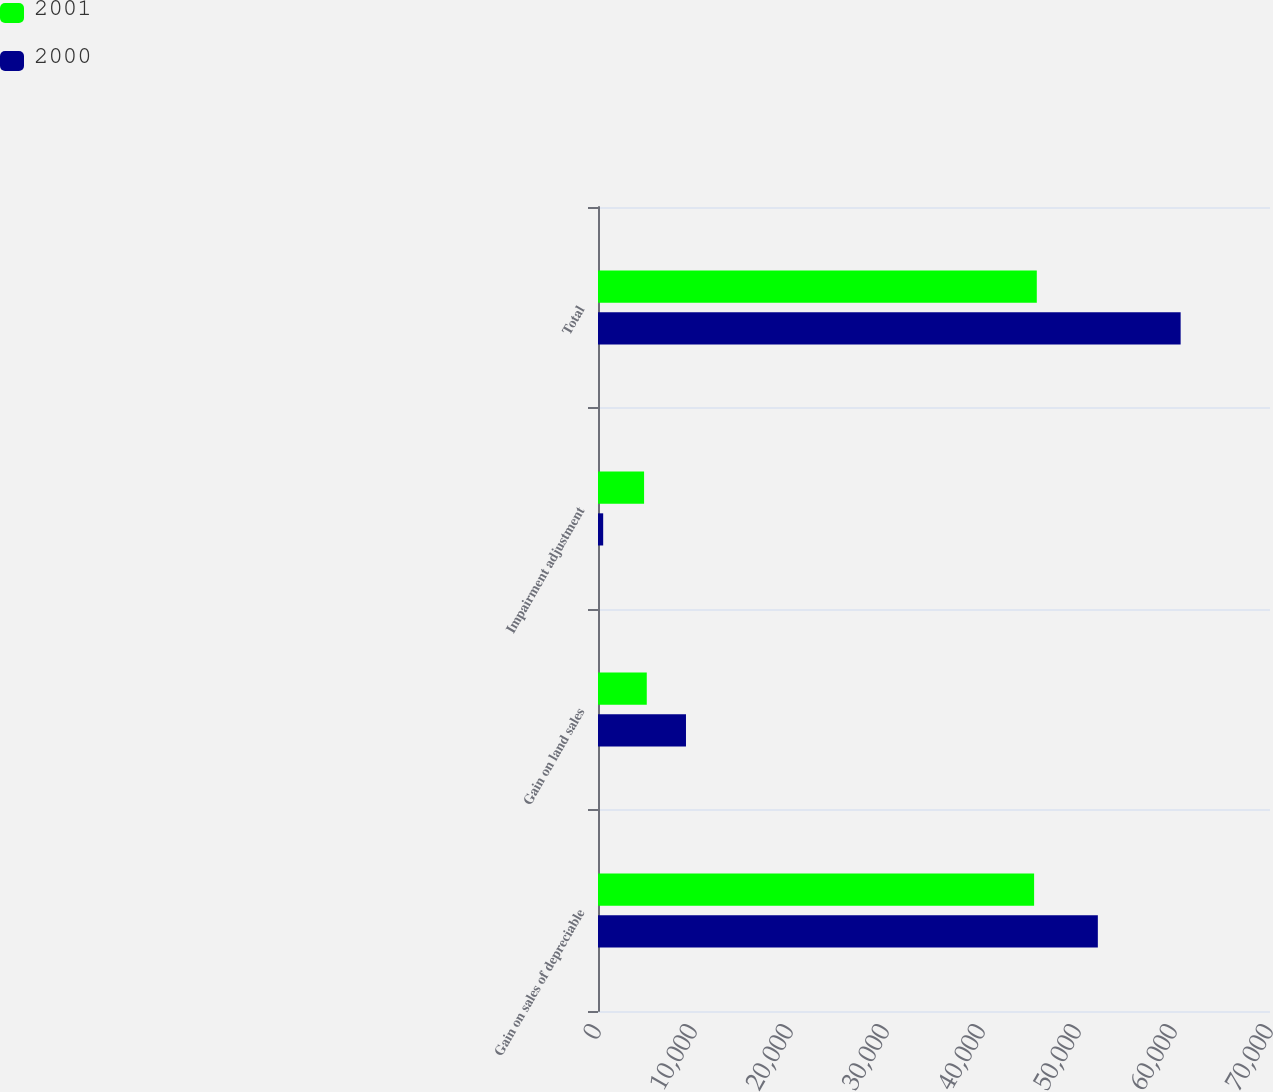<chart> <loc_0><loc_0><loc_500><loc_500><stacked_bar_chart><ecel><fcel>Gain on sales of depreciable<fcel>Gain on land sales<fcel>Impairment adjustment<fcel>Total<nl><fcel>2001<fcel>45428<fcel>5080<fcel>4800<fcel>45708<nl><fcel>2000<fcel>52067<fcel>9165<fcel>540<fcel>60692<nl></chart> 